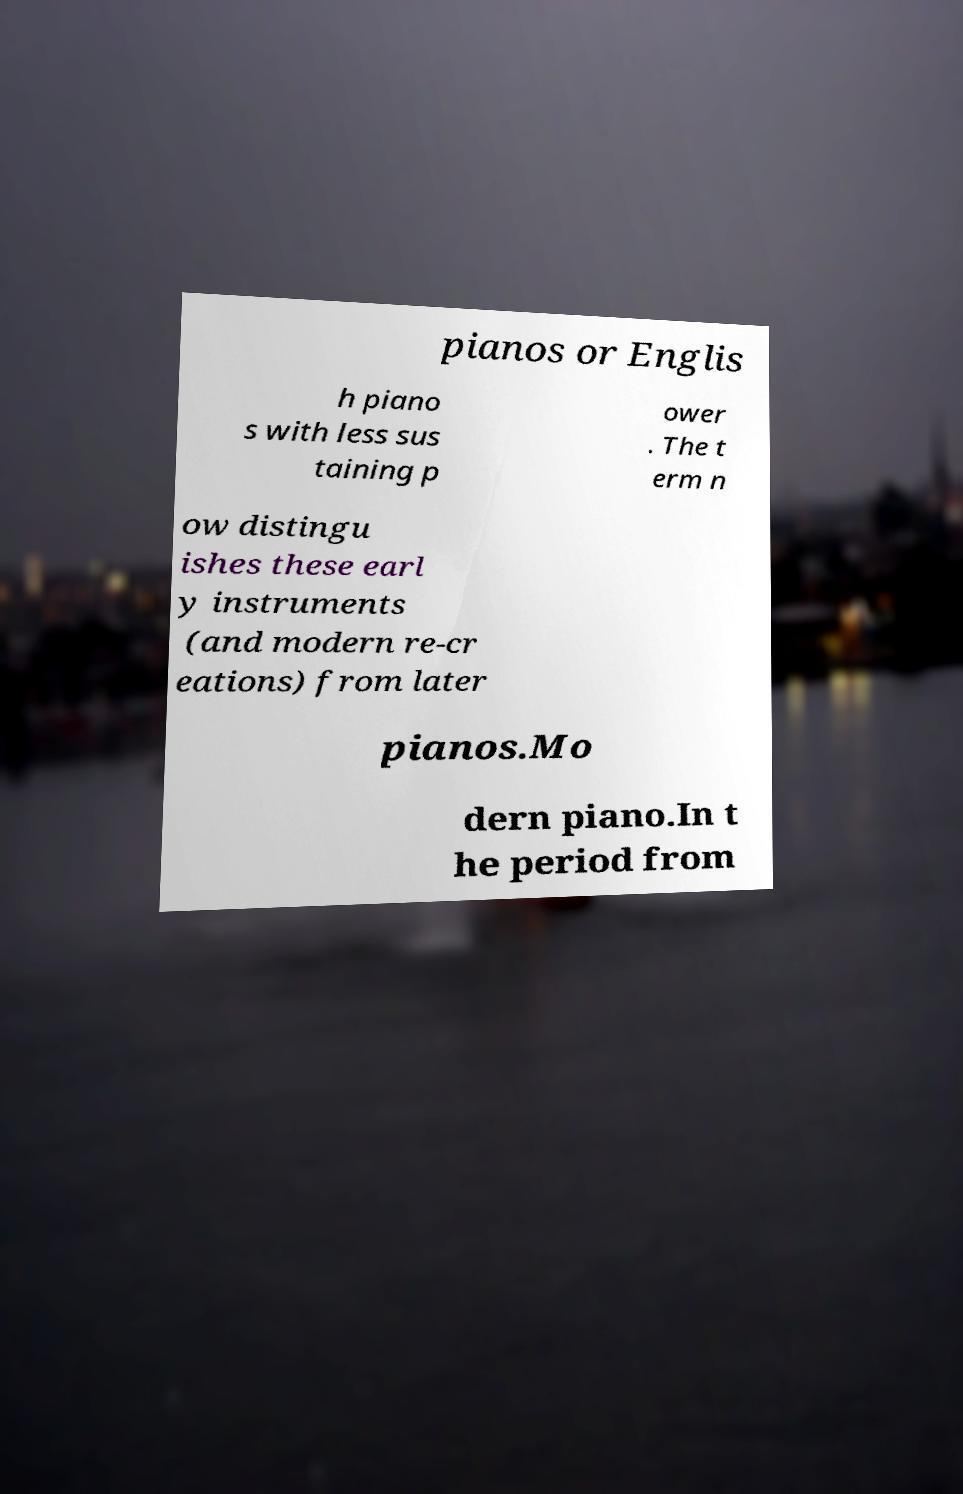Can you accurately transcribe the text from the provided image for me? pianos or Englis h piano s with less sus taining p ower . The t erm n ow distingu ishes these earl y instruments (and modern re-cr eations) from later pianos.Mo dern piano.In t he period from 